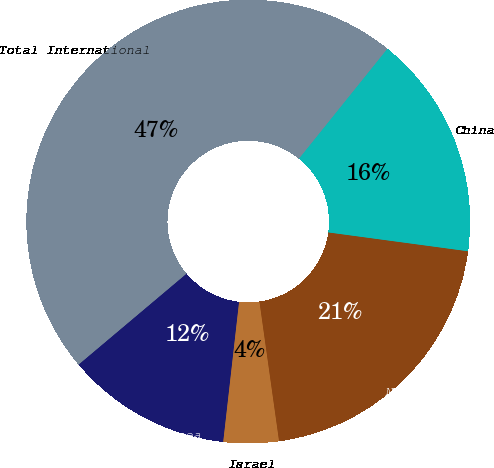Convert chart to OTSL. <chart><loc_0><loc_0><loc_500><loc_500><pie_chart><fcel>Equatorial Guinea<fcel>Israel<fcel>North Sea<fcel>China<fcel>Total International<nl><fcel>12.06%<fcel>4.02%<fcel>20.64%<fcel>16.35%<fcel>46.92%<nl></chart> 